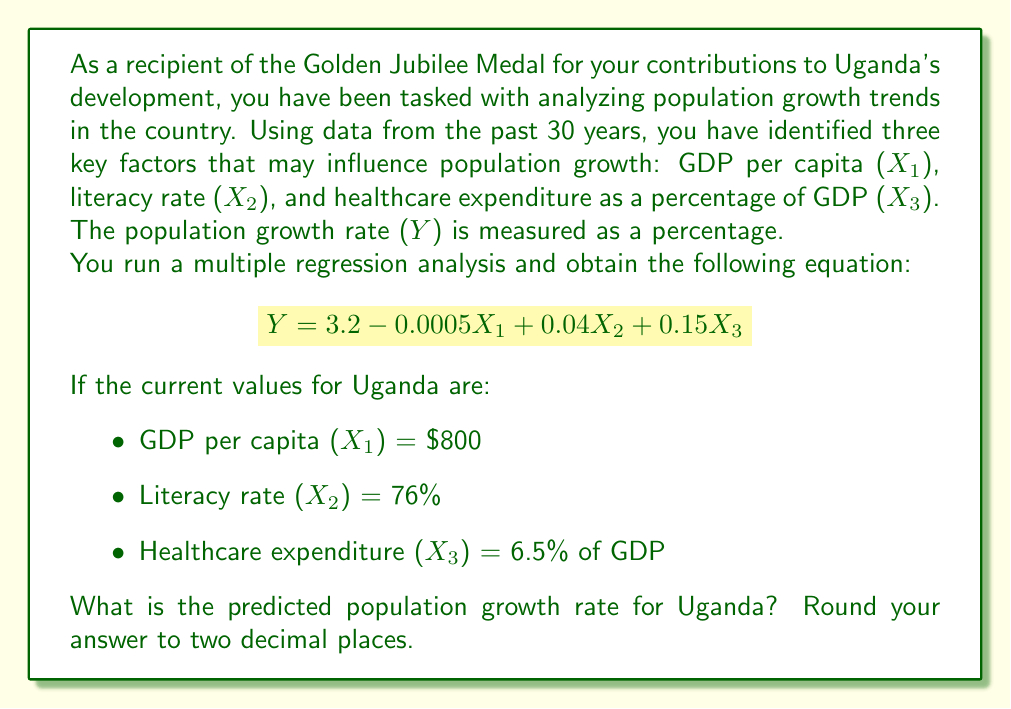Can you solve this math problem? To solve this problem, we need to use the multiple regression equation provided and substitute the given values for each independent variable. Let's go through this step-by-step:

1. The multiple regression equation is:
   $$Y = 3.2 - 0.0005X_1 + 0.04X_2 + 0.15X_3$$

2. We are given the following values:
   $X_1$ (GDP per capita) = $800
   $X_2$ (Literacy rate) = 76%
   $X_3$ (Healthcare expenditure) = 6.5% of GDP

3. Let's substitute these values into the equation:
   $$Y = 3.2 - 0.0005(800) + 0.04(76) + 0.15(6.5)$$

4. Now, let's calculate each term:
   - $3.2$ (constant term)
   - $-0.0005(800) = -0.4$
   - $0.04(76) = 3.04$
   - $0.15(6.5) = 0.975$

5. Add all these terms together:
   $$Y = 3.2 + (-0.4) + 3.04 + 0.975$$
   $$Y = 6.815$$

6. Rounding to two decimal places:
   $$Y ≈ 6.82$$

Therefore, the predicted population growth rate for Uganda is 6.82%.
Answer: 6.82% 